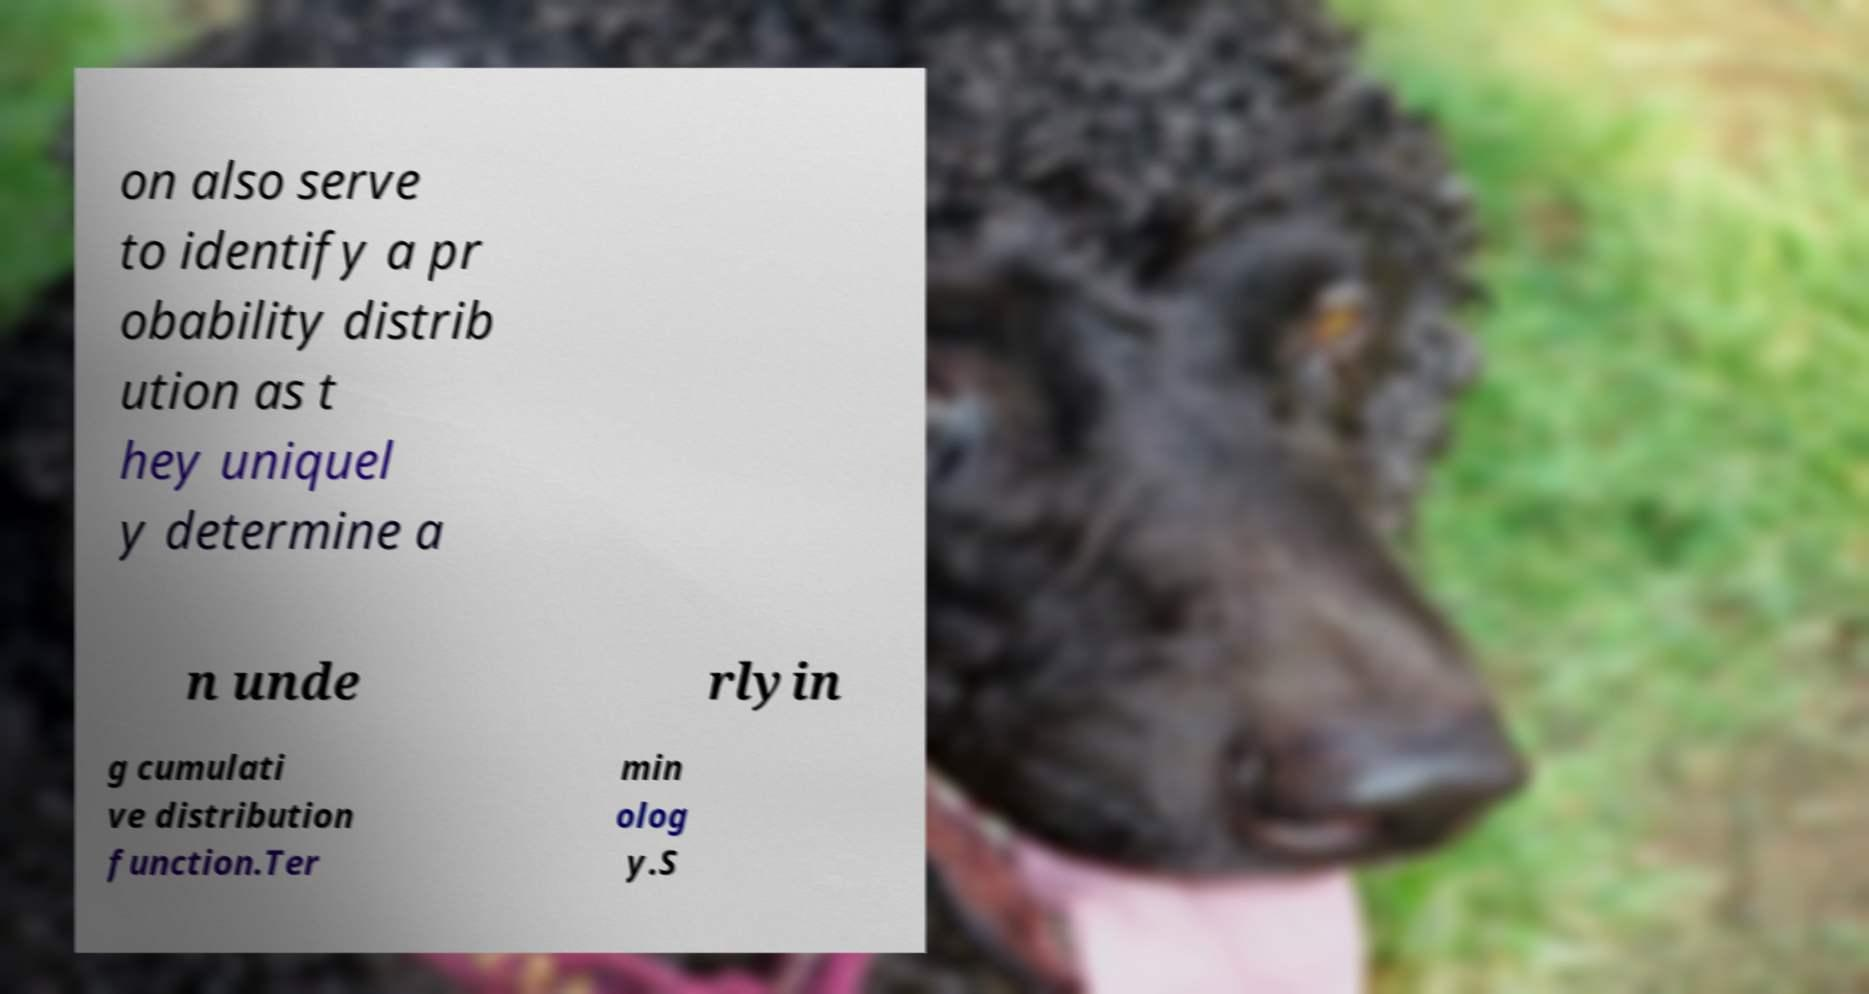Please read and relay the text visible in this image. What does it say? on also serve to identify a pr obability distrib ution as t hey uniquel y determine a n unde rlyin g cumulati ve distribution function.Ter min olog y.S 